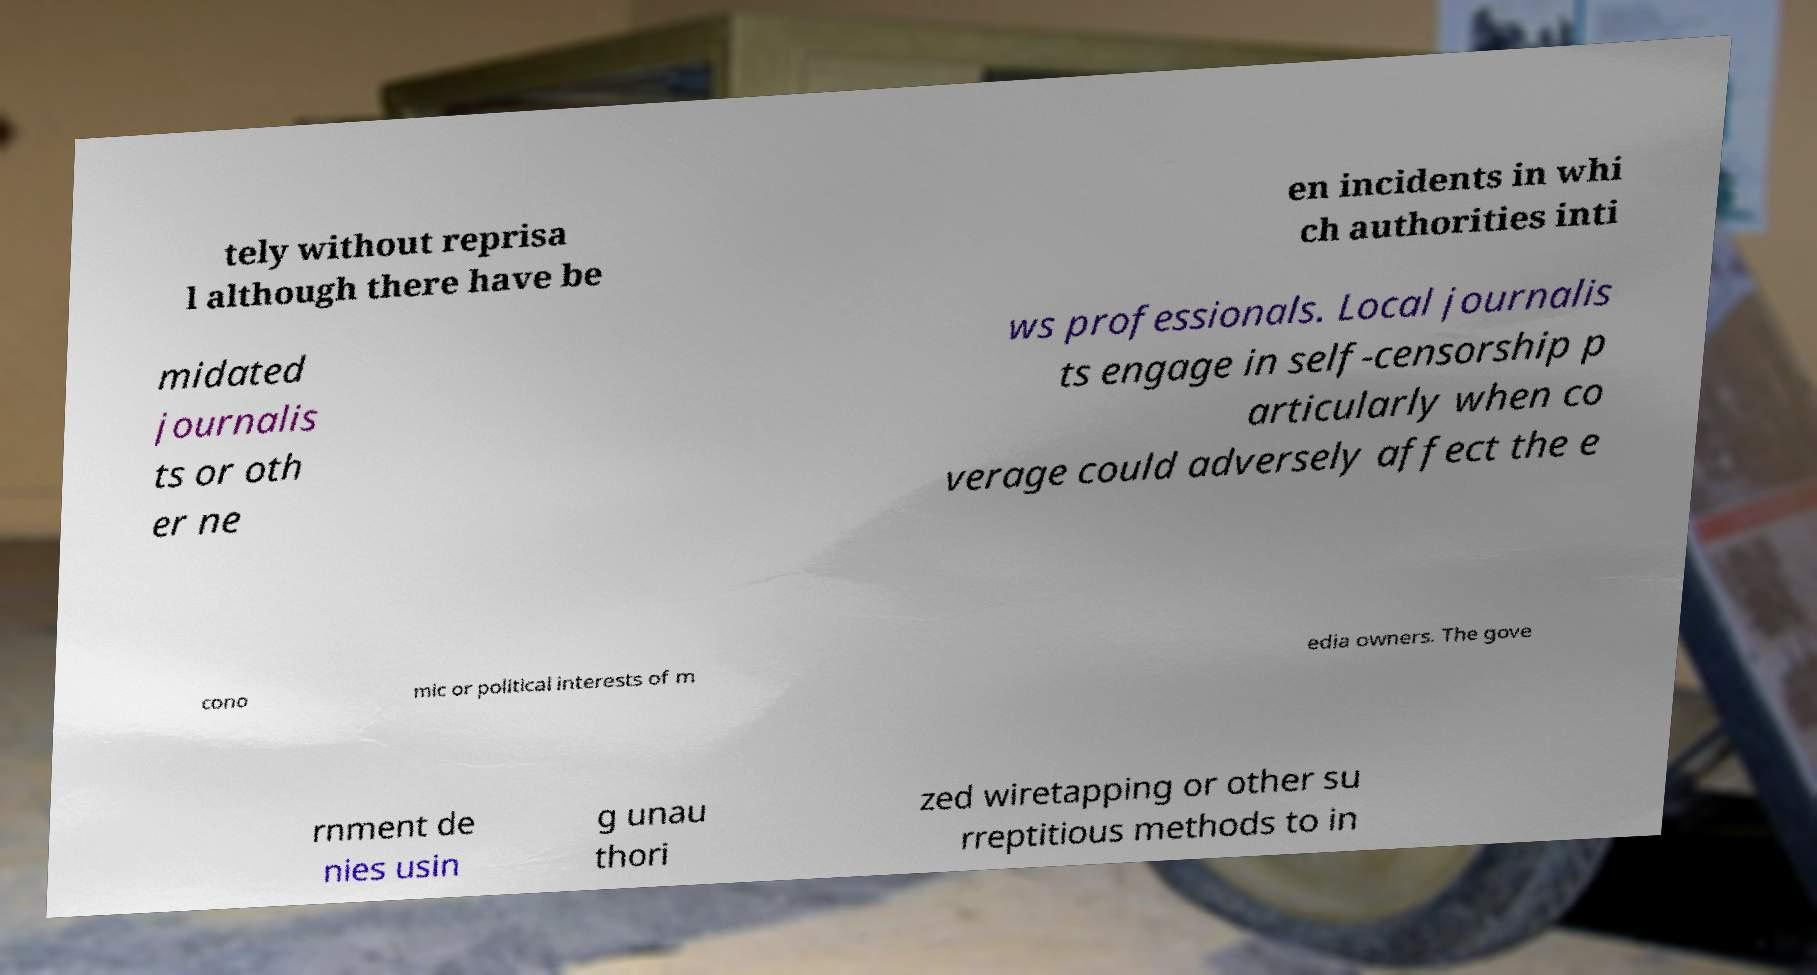Please read and relay the text visible in this image. What does it say? tely without reprisa l although there have be en incidents in whi ch authorities inti midated journalis ts or oth er ne ws professionals. Local journalis ts engage in self-censorship p articularly when co verage could adversely affect the e cono mic or political interests of m edia owners. The gove rnment de nies usin g unau thori zed wiretapping or other su rreptitious methods to in 